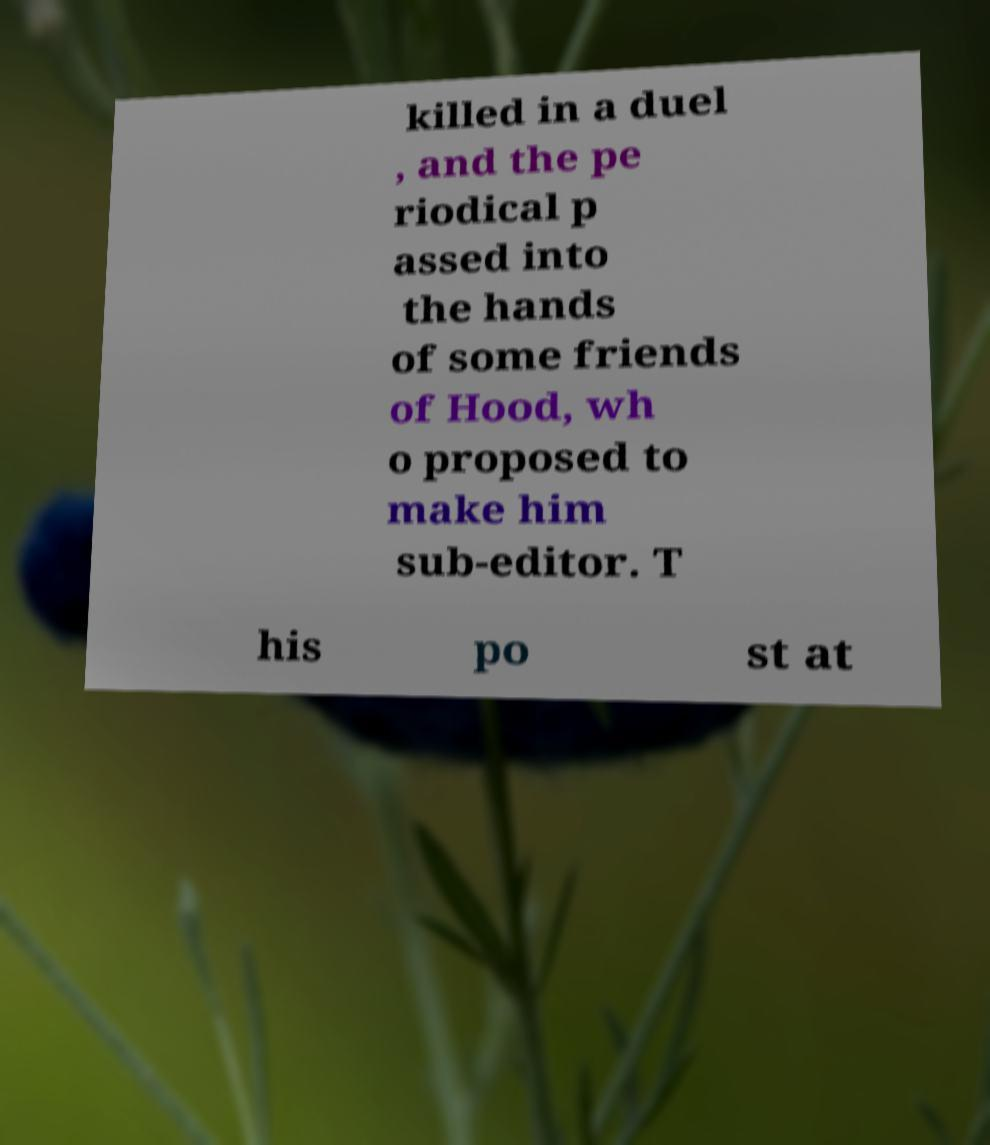Could you assist in decoding the text presented in this image and type it out clearly? killed in a duel , and the pe riodical p assed into the hands of some friends of Hood, wh o proposed to make him sub-editor. T his po st at 